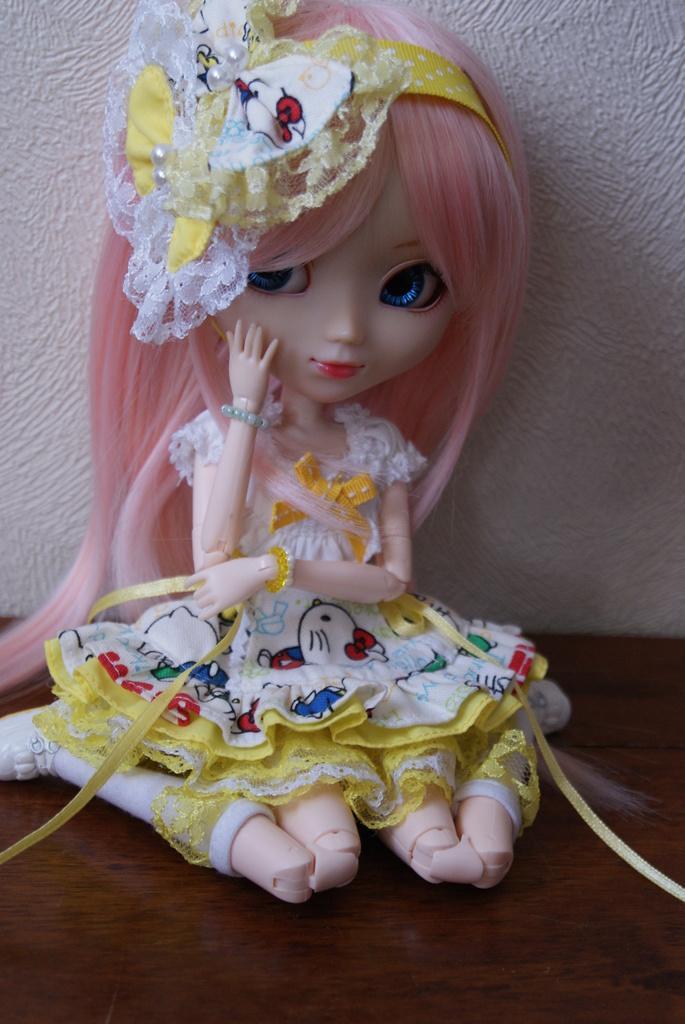How would you summarize this image in a sentence or two? In this image I can see a doll in the centre and I can see she is wearing yellow and white colour dress. I can also see she is wearing a yellow color hair band. 